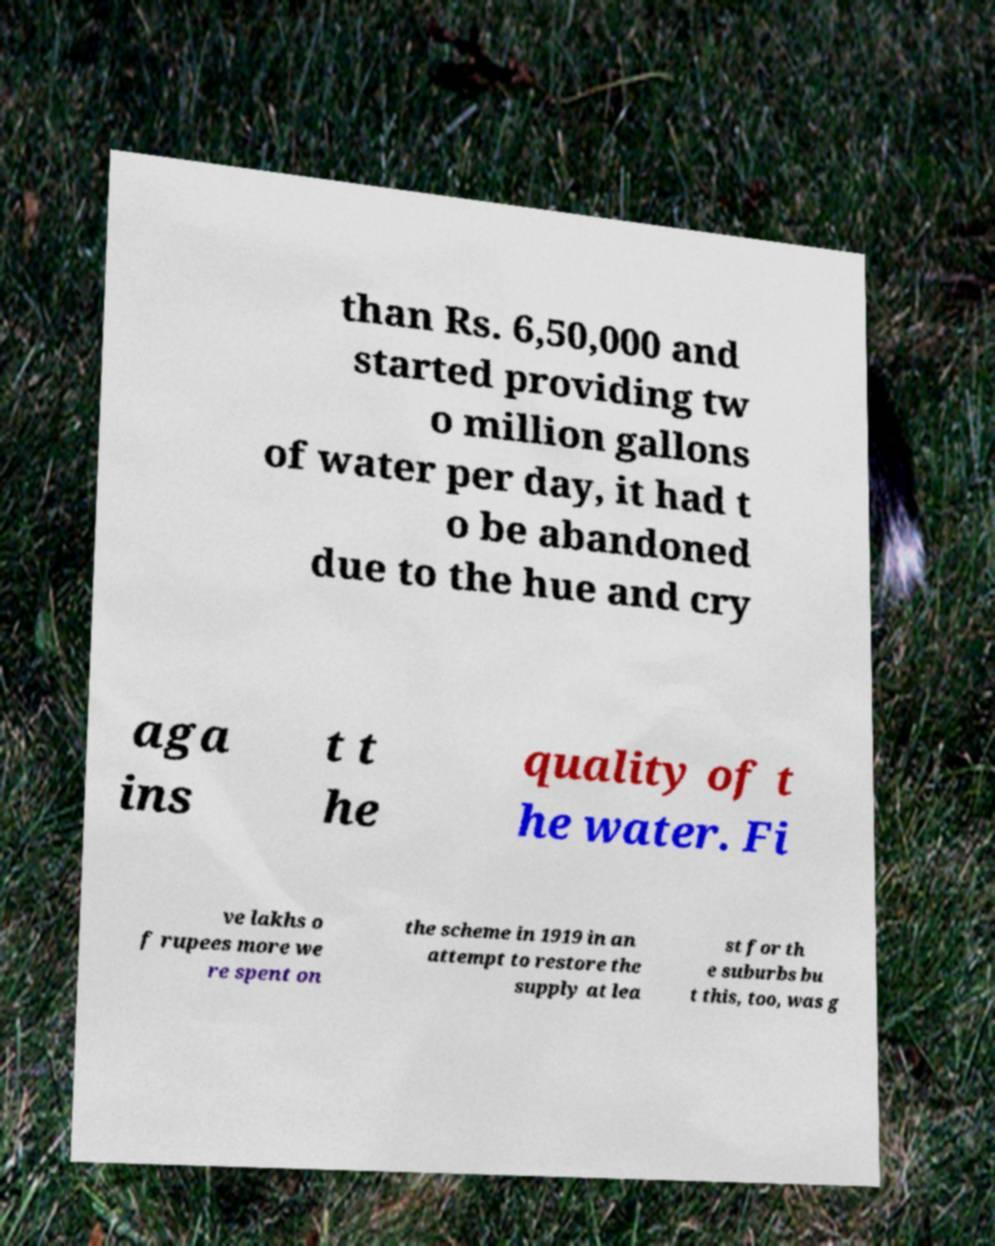Can you accurately transcribe the text from the provided image for me? than Rs. 6,50,000 and started providing tw o million gallons of water per day, it had t o be abandoned due to the hue and cry aga ins t t he quality of t he water. Fi ve lakhs o f rupees more we re spent on the scheme in 1919 in an attempt to restore the supply at lea st for th e suburbs bu t this, too, was g 